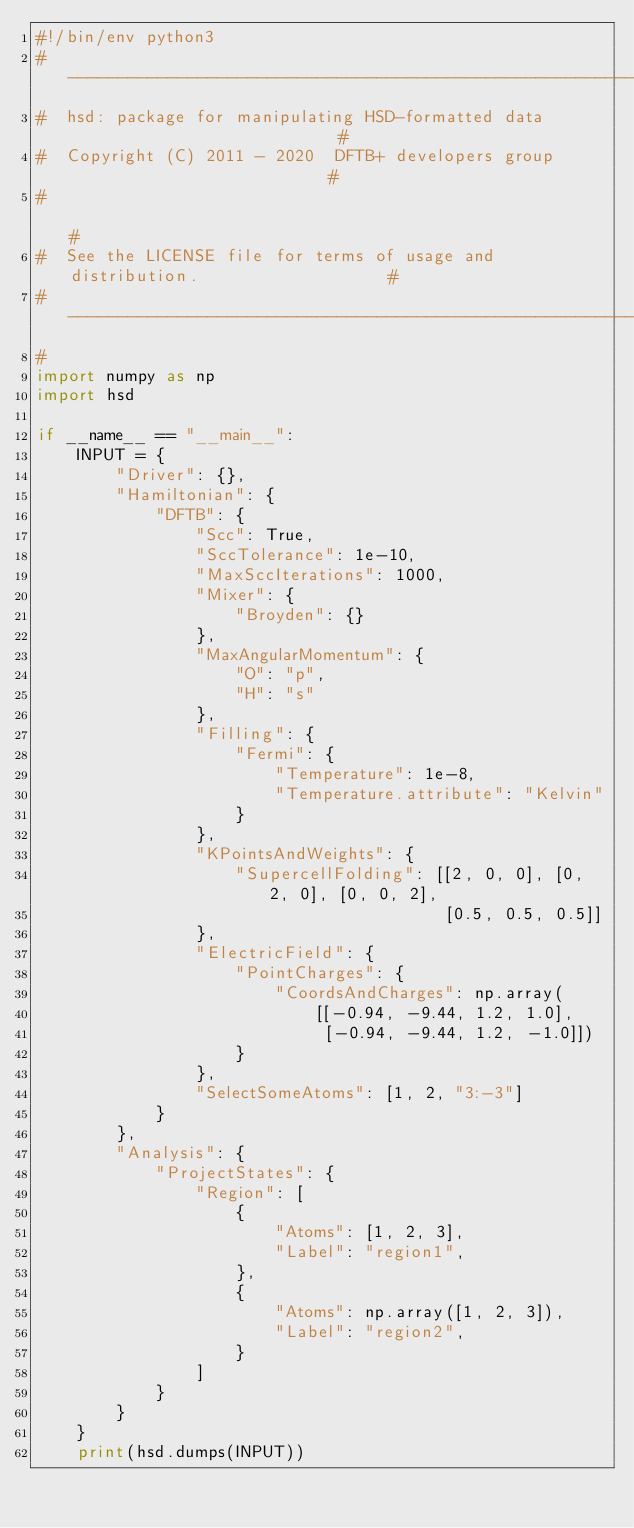<code> <loc_0><loc_0><loc_500><loc_500><_Python_>#!/bin/env python3
#------------------------------------------------------------------------------#
#  hsd: package for manipulating HSD-formatted data                            #
#  Copyright (C) 2011 - 2020  DFTB+ developers group                           #
#                                                                              #
#  See the LICENSE file for terms of usage and distribution.                   #
#------------------------------------------------------------------------------#
#
import numpy as np
import hsd

if __name__ == "__main__":
    INPUT = {
        "Driver": {},
        "Hamiltonian": {
            "DFTB": {
                "Scc": True,
                "SccTolerance": 1e-10,
                "MaxSccIterations": 1000,
                "Mixer": {
                    "Broyden": {}
                },
                "MaxAngularMomentum": {
                    "O": "p",
                    "H": "s"
                },
                "Filling": {
                    "Fermi": {
                        "Temperature": 1e-8,
                        "Temperature.attribute": "Kelvin"
                    }
                },
                "KPointsAndWeights": {
                    "SupercellFolding": [[2, 0, 0], [0, 2, 0], [0, 0, 2],
                                         [0.5, 0.5, 0.5]]
                },
                "ElectricField": {
                    "PointCharges": {
                        "CoordsAndCharges": np.array(
                            [[-0.94, -9.44, 1.2, 1.0],
                             [-0.94, -9.44, 1.2, -1.0]])
                    }
                },
                "SelectSomeAtoms": [1, 2, "3:-3"]
            }
        },
        "Analysis": {
            "ProjectStates": {
                "Region": [
                    {
                        "Atoms": [1, 2, 3],
                        "Label": "region1",
                    },
                    {
                        "Atoms": np.array([1, 2, 3]),
                        "Label": "region2",
                    }
                ]
            }
        }
    }
    print(hsd.dumps(INPUT))
</code> 